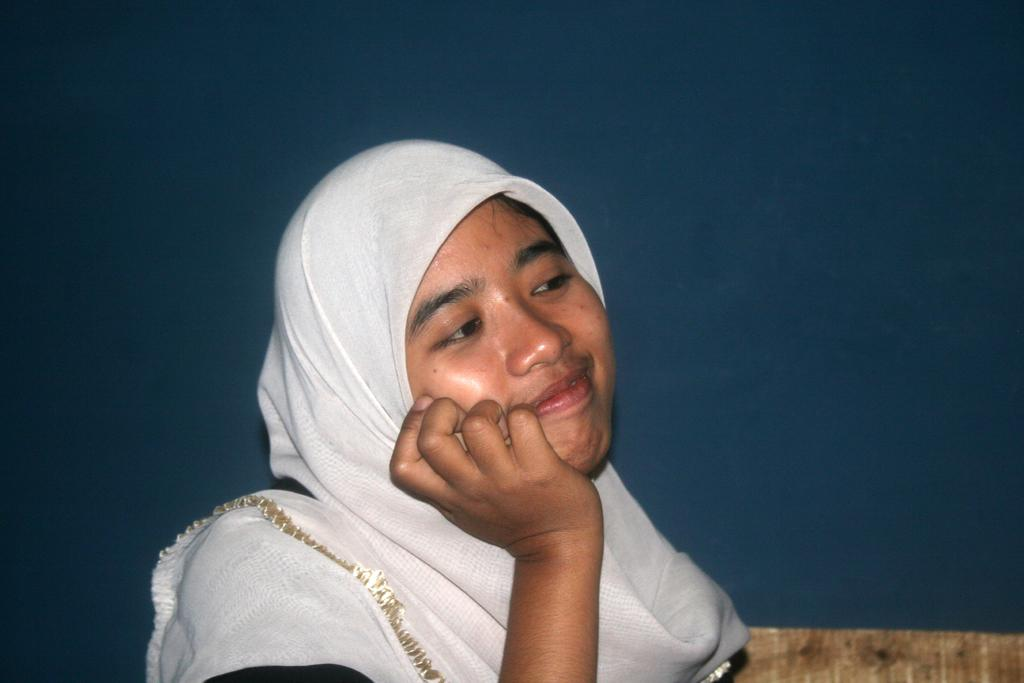Who or what is present in the image? There is a person in the image. What is the person doing or expressing? The person is smiling. What is the person wearing on her head? The person is wearing a white scarf around her head. What can be seen in the background of the image? There is a wall in the background of the image. What invention is the person holding in the image? There is no invention visible in the image; the person is not holding anything. 